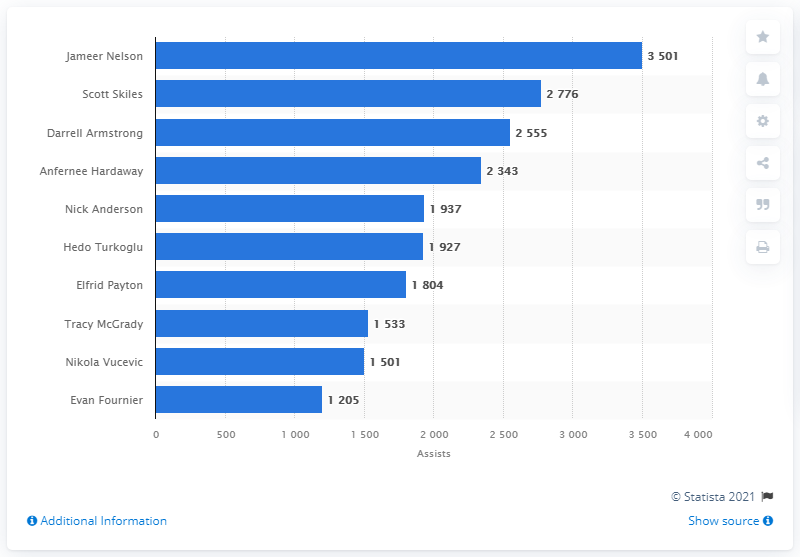Mention a couple of crucial points in this snapshot. The Orlando Magic's career assists leader is Jameer Nelson. 